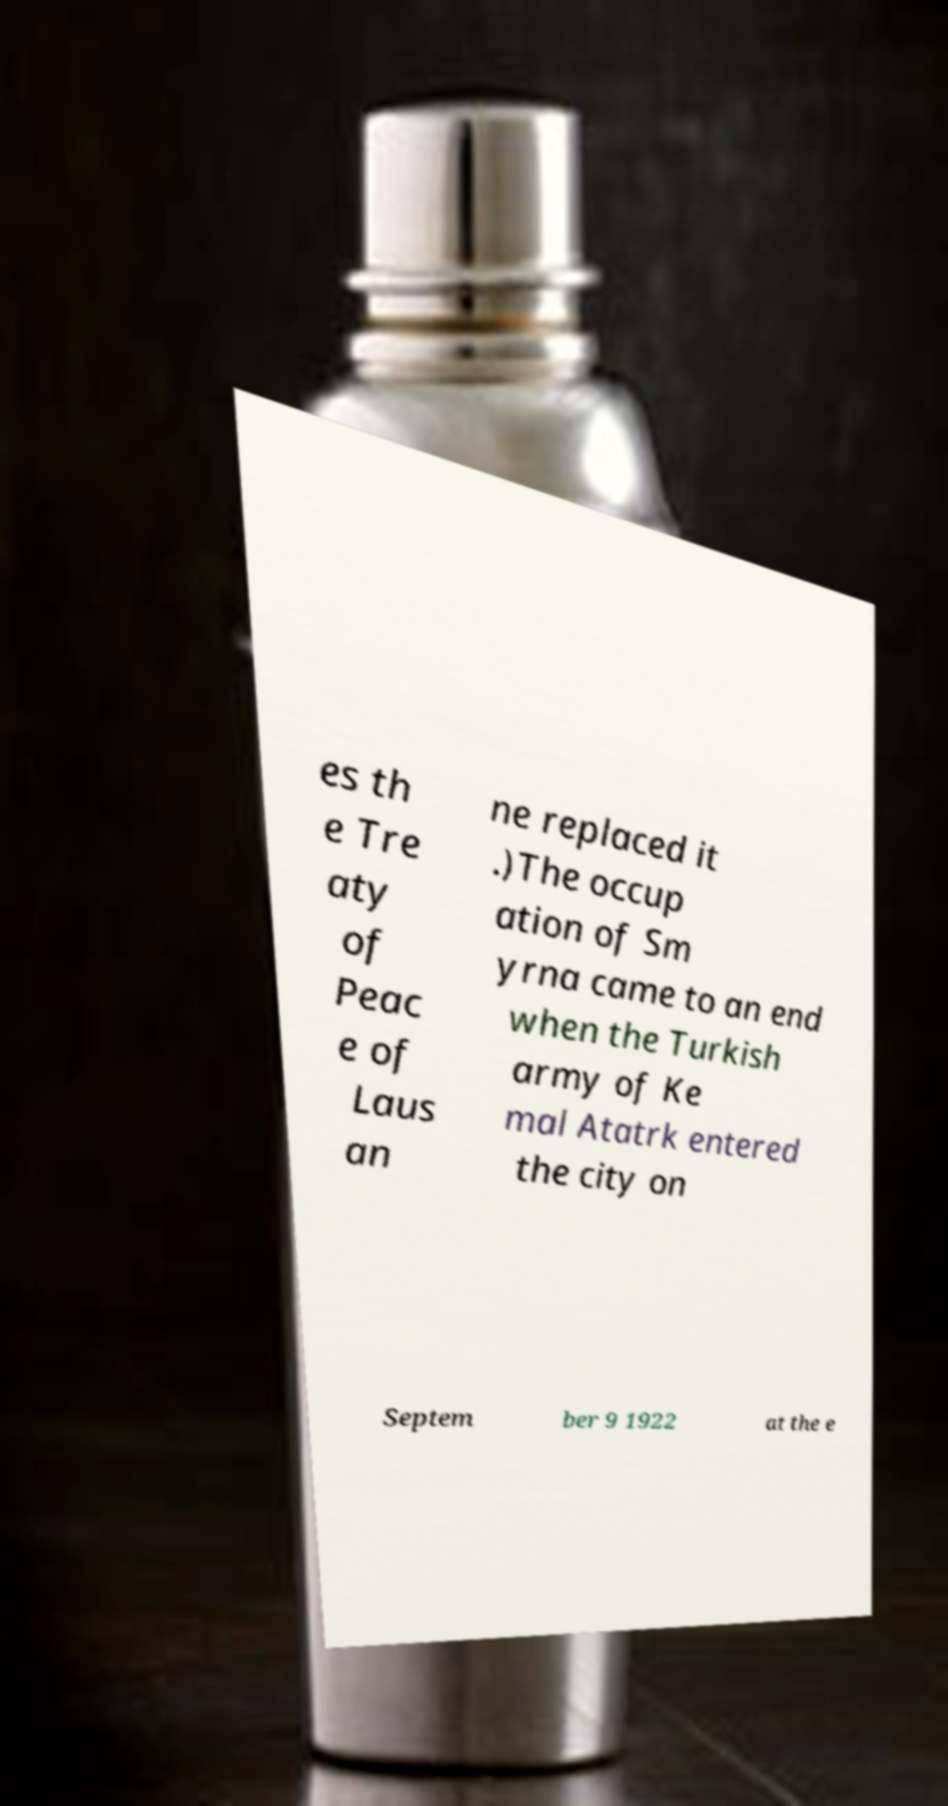Please read and relay the text visible in this image. What does it say? es th e Tre aty of Peac e of Laus an ne replaced it .)The occup ation of Sm yrna came to an end when the Turkish army of Ke mal Atatrk entered the city on Septem ber 9 1922 at the e 